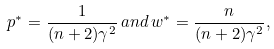Convert formula to latex. <formula><loc_0><loc_0><loc_500><loc_500>p ^ { * } = \frac { 1 } { ( n + 2 ) \gamma ^ { 2 } } \, a n d \, w ^ { * } = \frac { n } { ( n + 2 ) \gamma ^ { 2 } } ,</formula> 